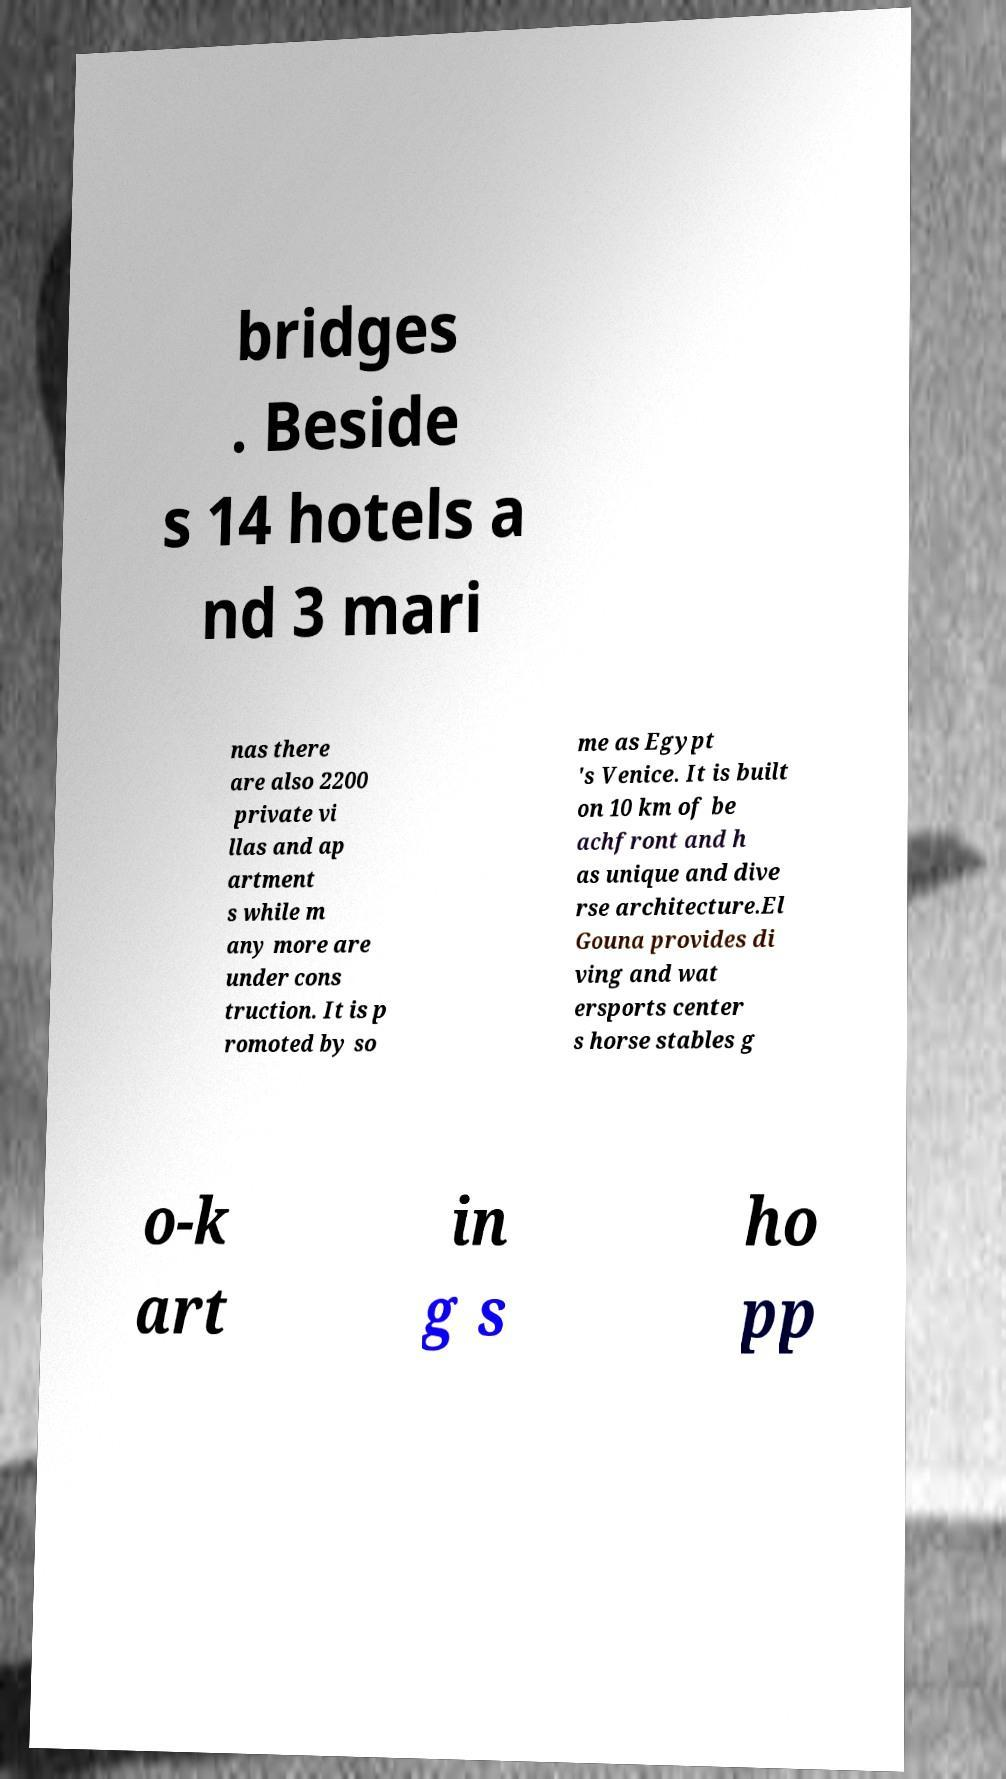Please read and relay the text visible in this image. What does it say? bridges . Beside s 14 hotels a nd 3 mari nas there are also 2200 private vi llas and ap artment s while m any more are under cons truction. It is p romoted by so me as Egypt 's Venice. It is built on 10 km of be achfront and h as unique and dive rse architecture.El Gouna provides di ving and wat ersports center s horse stables g o-k art in g s ho pp 